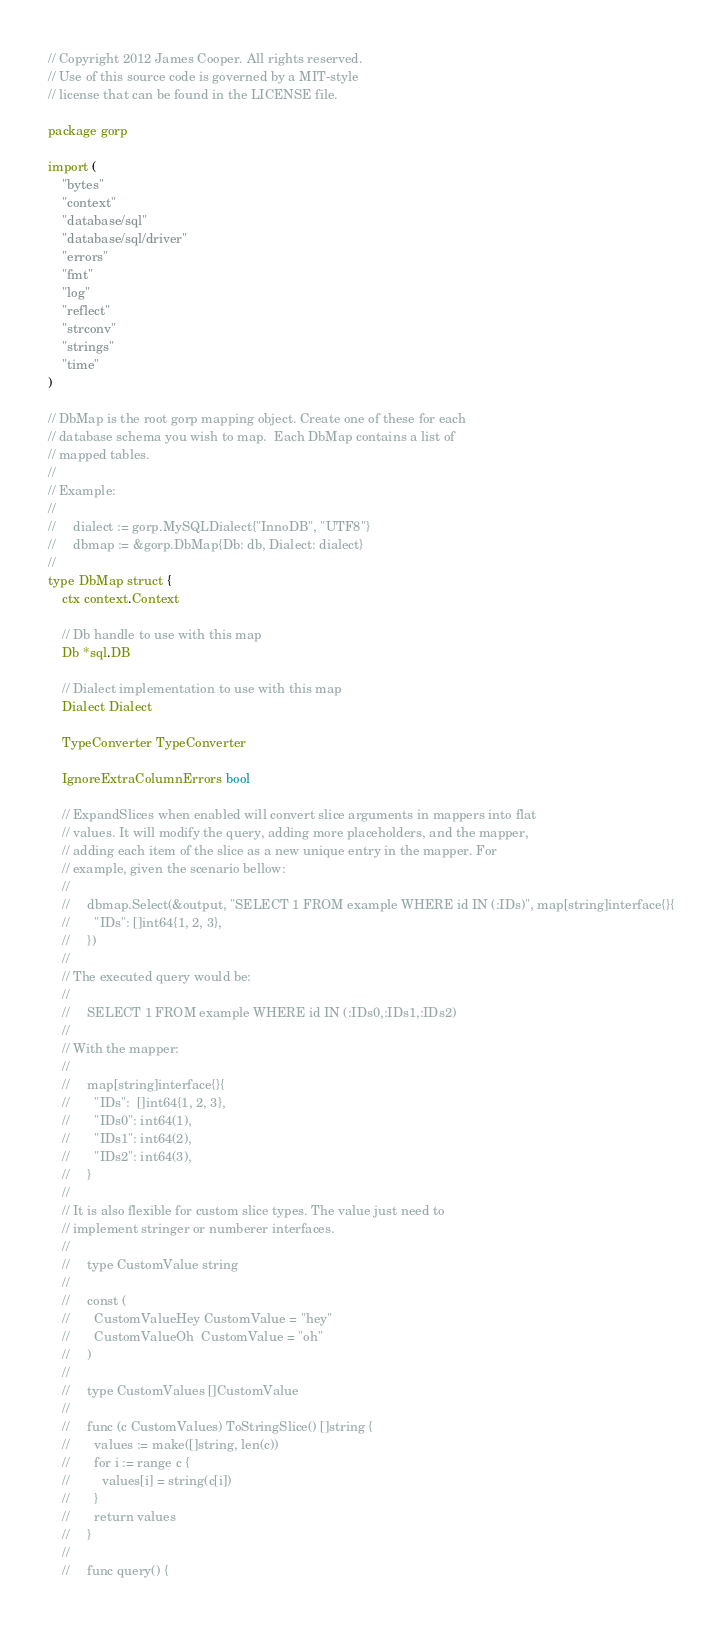<code> <loc_0><loc_0><loc_500><loc_500><_Go_>// Copyright 2012 James Cooper. All rights reserved.
// Use of this source code is governed by a MIT-style
// license that can be found in the LICENSE file.

package gorp

import (
	"bytes"
	"context"
	"database/sql"
	"database/sql/driver"
	"errors"
	"fmt"
	"log"
	"reflect"
	"strconv"
	"strings"
	"time"
)

// DbMap is the root gorp mapping object. Create one of these for each
// database schema you wish to map.  Each DbMap contains a list of
// mapped tables.
//
// Example:
//
//     dialect := gorp.MySQLDialect{"InnoDB", "UTF8"}
//     dbmap := &gorp.DbMap{Db: db, Dialect: dialect}
//
type DbMap struct {
	ctx context.Context

	// Db handle to use with this map
	Db *sql.DB

	// Dialect implementation to use with this map
	Dialect Dialect

	TypeConverter TypeConverter

	IgnoreExtraColumnErrors bool

	// ExpandSlices when enabled will convert slice arguments in mappers into flat
	// values. It will modify the query, adding more placeholders, and the mapper,
	// adding each item of the slice as a new unique entry in the mapper. For
	// example, given the scenario bellow:
	//
	//     dbmap.Select(&output, "SELECT 1 FROM example WHERE id IN (:IDs)", map[string]interface{}{
	//       "IDs": []int64{1, 2, 3},
	//     })
	//
	// The executed query would be:
	//
	//     SELECT 1 FROM example WHERE id IN (:IDs0,:IDs1,:IDs2)
	//
	// With the mapper:
	//
	//     map[string]interface{}{
	//       "IDs":  []int64{1, 2, 3},
	//       "IDs0": int64(1),
	//       "IDs1": int64(2),
	//       "IDs2": int64(3),
	//     }
	//
	// It is also flexible for custom slice types. The value just need to
	// implement stringer or numberer interfaces.
	//
	//     type CustomValue string
	//
	//     const (
	//       CustomValueHey CustomValue = "hey"
	//       CustomValueOh  CustomValue = "oh"
	//     )
	//
	//     type CustomValues []CustomValue
	//
	//     func (c CustomValues) ToStringSlice() []string {
	//       values := make([]string, len(c))
	//       for i := range c {
	//         values[i] = string(c[i])
	//       }
	//       return values
	//     }
	//
	//     func query() {</code> 